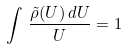Convert formula to latex. <formula><loc_0><loc_0><loc_500><loc_500>\int \, \frac { \tilde { \rho } ( U ) \, d U } { U } = 1</formula> 